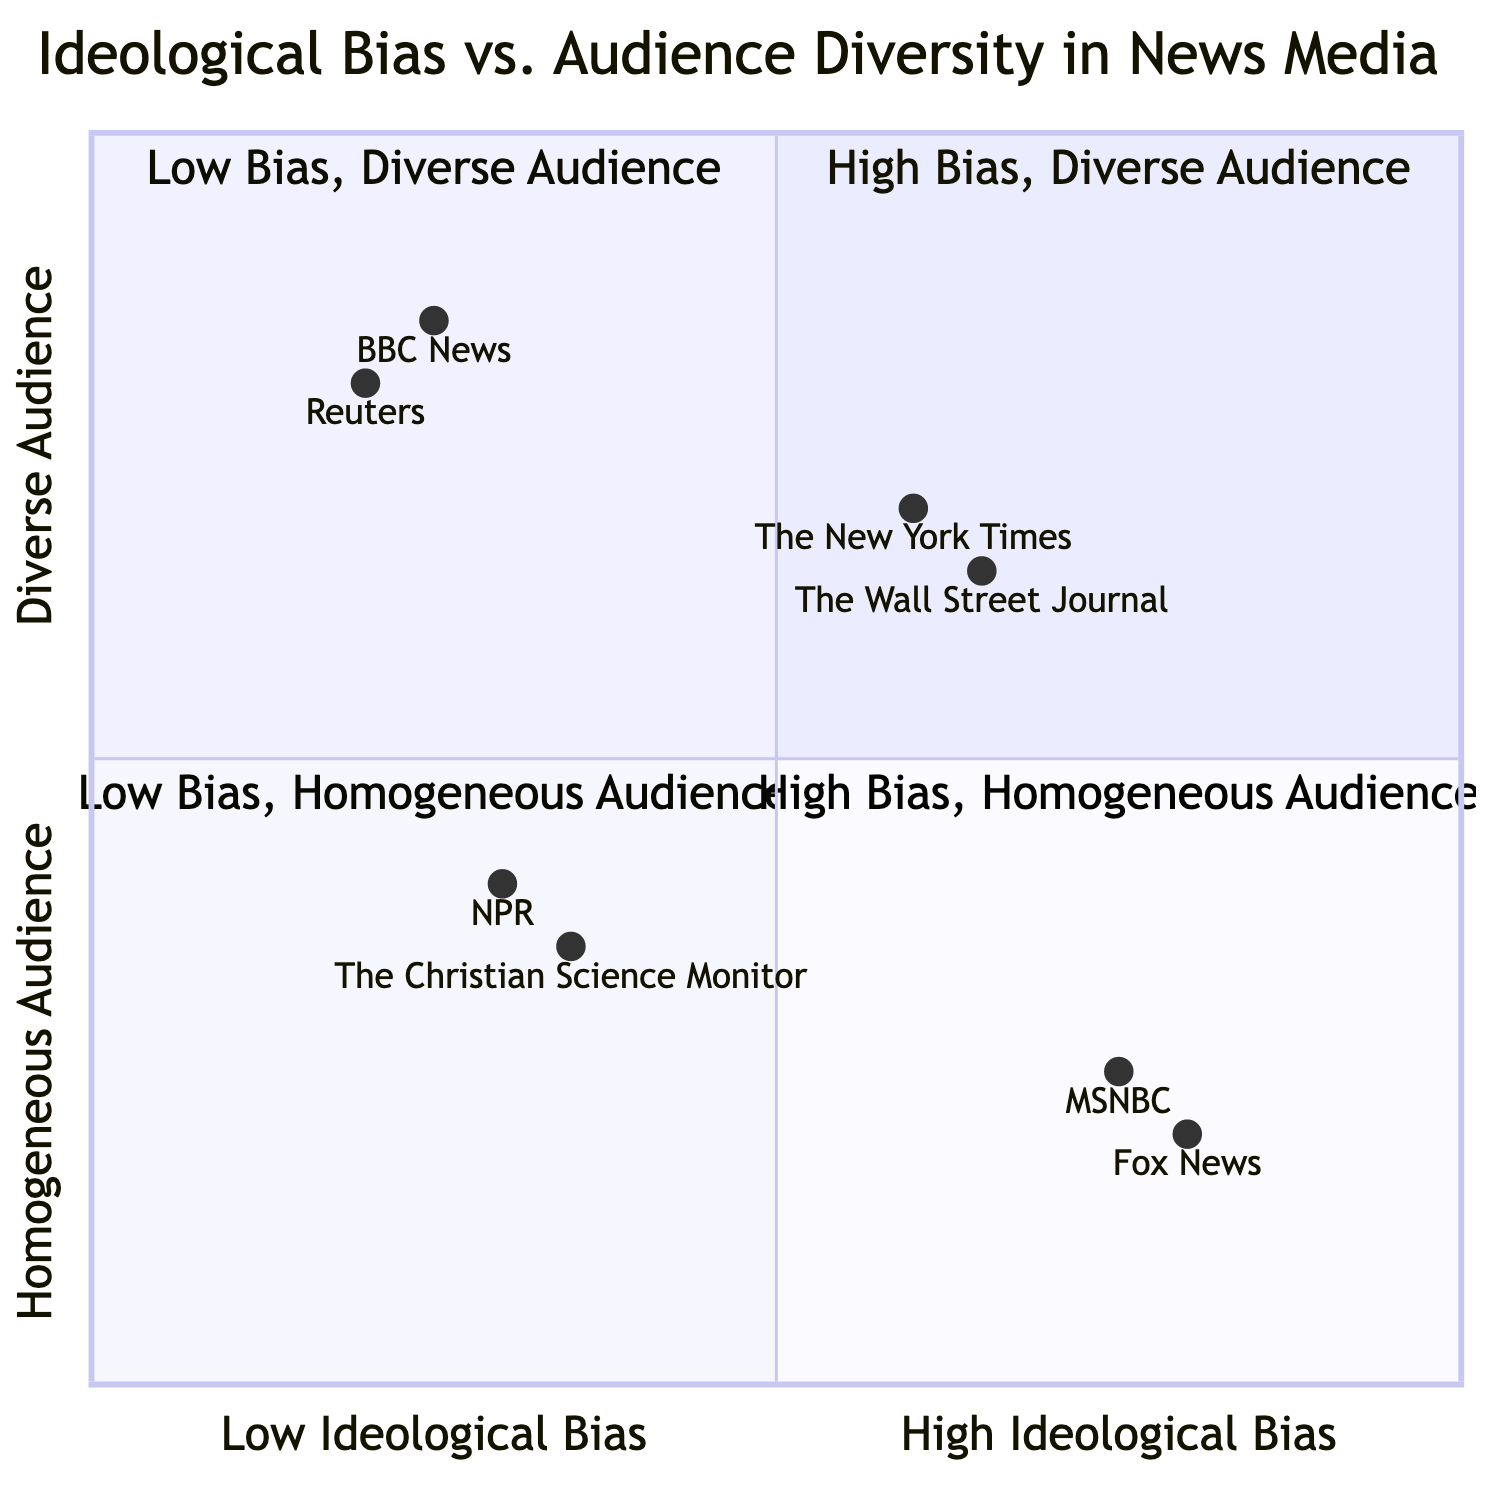What is the highest ideological bias rating among the news organizations? By reviewing the values assigned to each news organization, Fox News has the highest ideological bias rating of 0.8.
Answer: 0.8 Which news organization is in the "High Ideological Bias - Homogeneous Audience" quadrant? The diagram shows Fox News and MSNBC in this quadrant, both having high ideological bias and homogeneous audiences.
Answer: Fox News, MSNBC How many news organizations are categorized under "Low Ideological Bias - Diverse Audience"? The diagram shows Reuters and BBC News, thus there are two organizations under this category.
Answer: 2 What is the ideological bias rating of The New York Times? The New York Times has an ideological bias rating of 0.6.
Answer: 0.6 Which organization has the most diverse audience among those with high ideological bias? The Wall Street Journal is noted for a diverse audience while also having a high ideological bias of 0.65.
Answer: The Wall Street Journal Which quadrant contains organizations with low ideological bias and a homogeneous audience? The quadrant labeled "Low Ideological Bias - Homogeneous Audience" contains NPR and The Christian Science Monitor, indicating that both organizations have low bias and a similar audience.
Answer: Low Ideological Bias - Homogeneous Audience What is the ideological bias rating of NPR? NPR has a rating of 0.3 on the ideological bias scale, indicating a low bias.
Answer: 0.3 What is the y-axis value for Reuters? The y-axis value for Reuters is 0.8, indicating a high level of audience diversity.
Answer: 0.8 Which organization has a higher ideological bias, MSNBC or The New York Times? MSNBC has a higher bias value of 0.75 compared to The New York Times' value of 0.6.
Answer: MSNBC 